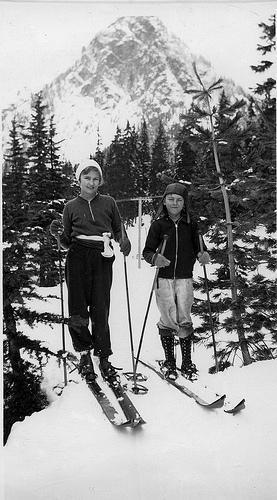How many women are in the picture?
Give a very brief answer. 2. 